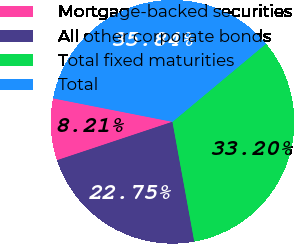Convert chart to OTSL. <chart><loc_0><loc_0><loc_500><loc_500><pie_chart><fcel>Mortgage-backed securities<fcel>All other corporate bonds<fcel>Total fixed maturities<fcel>Total<nl><fcel>8.21%<fcel>22.75%<fcel>33.2%<fcel>35.84%<nl></chart> 